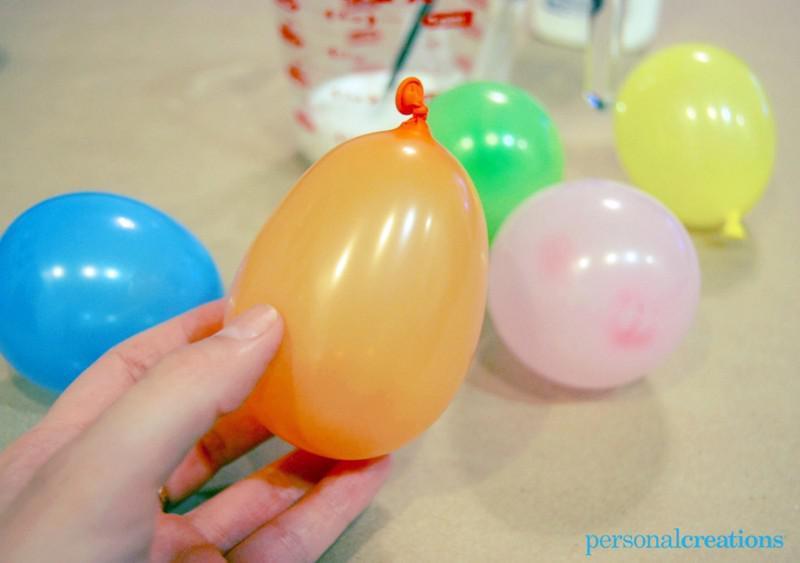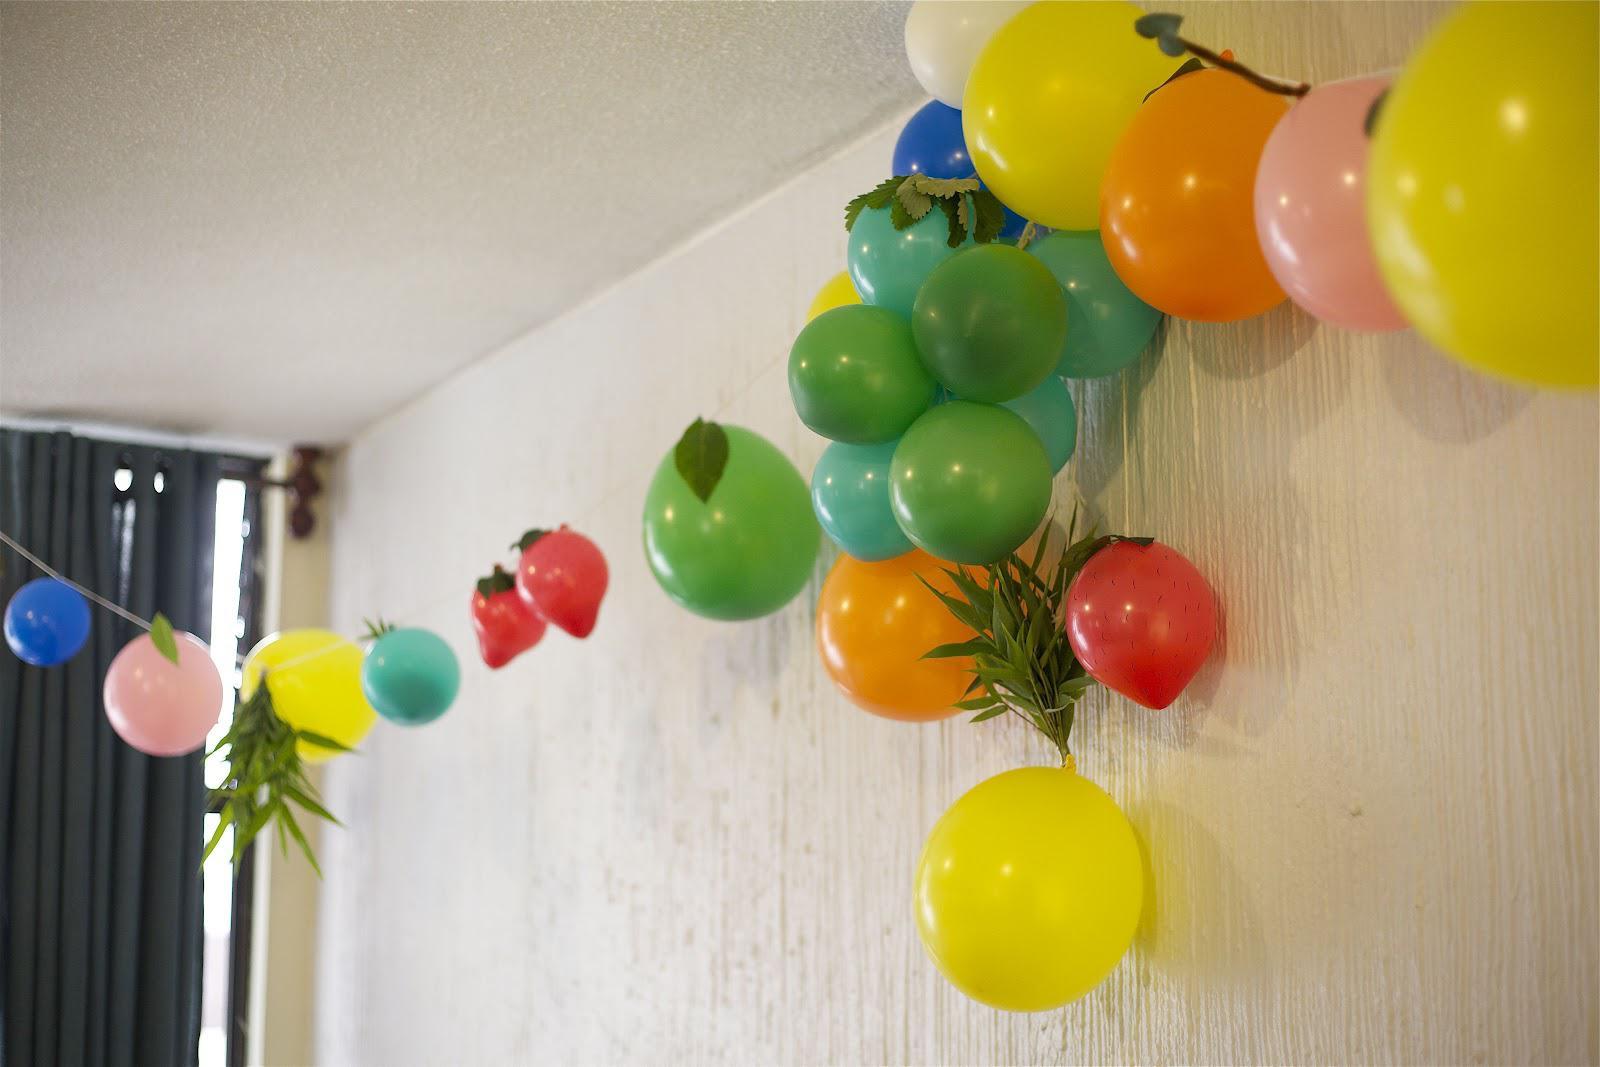The first image is the image on the left, the second image is the image on the right. Given the left and right images, does the statement "There are exactly three colorful objects in the left image." hold true? Answer yes or no. No. 